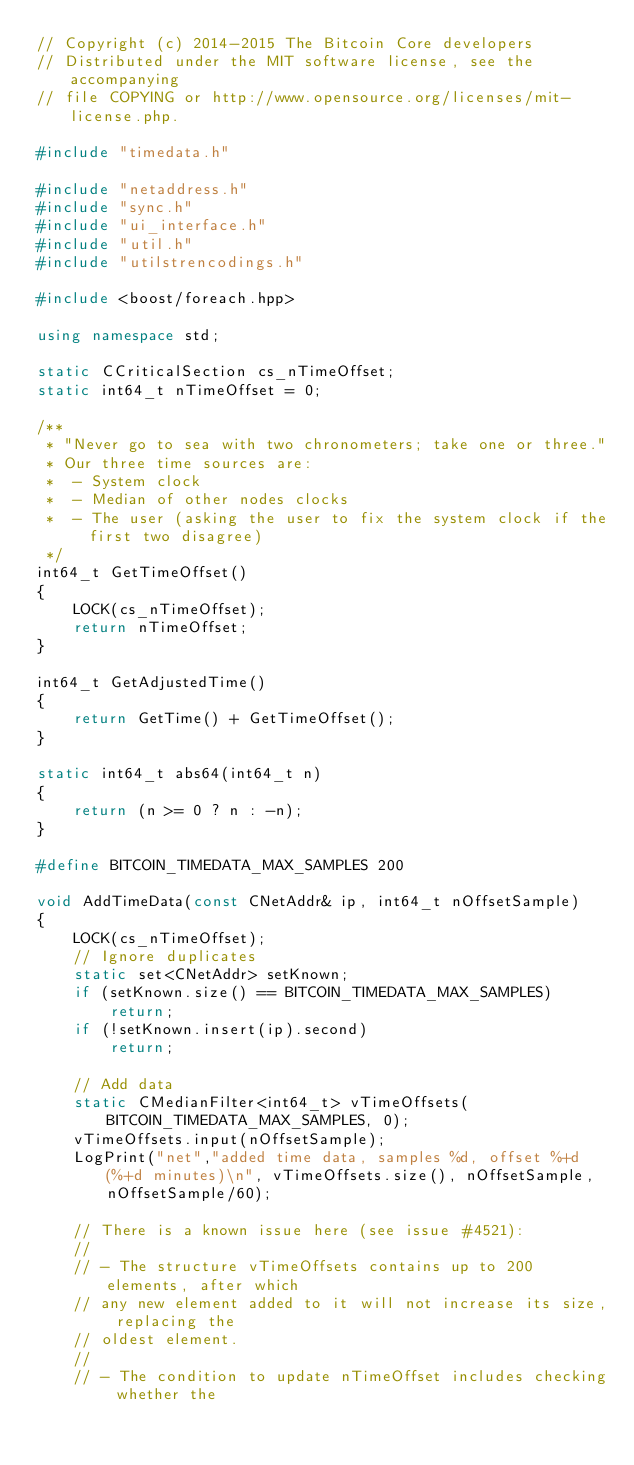<code> <loc_0><loc_0><loc_500><loc_500><_C++_>// Copyright (c) 2014-2015 The Bitcoin Core developers
// Distributed under the MIT software license, see the accompanying
// file COPYING or http://www.opensource.org/licenses/mit-license.php.

#include "timedata.h"

#include "netaddress.h"
#include "sync.h"
#include "ui_interface.h"
#include "util.h"
#include "utilstrencodings.h"

#include <boost/foreach.hpp>

using namespace std;

static CCriticalSection cs_nTimeOffset;
static int64_t nTimeOffset = 0;

/**
 * "Never go to sea with two chronometers; take one or three."
 * Our three time sources are:
 *  - System clock
 *  - Median of other nodes clocks
 *  - The user (asking the user to fix the system clock if the first two disagree)
 */
int64_t GetTimeOffset()
{
    LOCK(cs_nTimeOffset);
    return nTimeOffset;
}

int64_t GetAdjustedTime()
{
    return GetTime() + GetTimeOffset();
}

static int64_t abs64(int64_t n)
{
    return (n >= 0 ? n : -n);
}

#define BITCOIN_TIMEDATA_MAX_SAMPLES 200

void AddTimeData(const CNetAddr& ip, int64_t nOffsetSample)
{
    LOCK(cs_nTimeOffset);
    // Ignore duplicates
    static set<CNetAddr> setKnown;
    if (setKnown.size() == BITCOIN_TIMEDATA_MAX_SAMPLES)
        return;
    if (!setKnown.insert(ip).second)
        return;

    // Add data
    static CMedianFilter<int64_t> vTimeOffsets(BITCOIN_TIMEDATA_MAX_SAMPLES, 0);
    vTimeOffsets.input(nOffsetSample);
    LogPrint("net","added time data, samples %d, offset %+d (%+d minutes)\n", vTimeOffsets.size(), nOffsetSample, nOffsetSample/60);

    // There is a known issue here (see issue #4521):
    //
    // - The structure vTimeOffsets contains up to 200 elements, after which
    // any new element added to it will not increase its size, replacing the
    // oldest element.
    //
    // - The condition to update nTimeOffset includes checking whether the</code> 